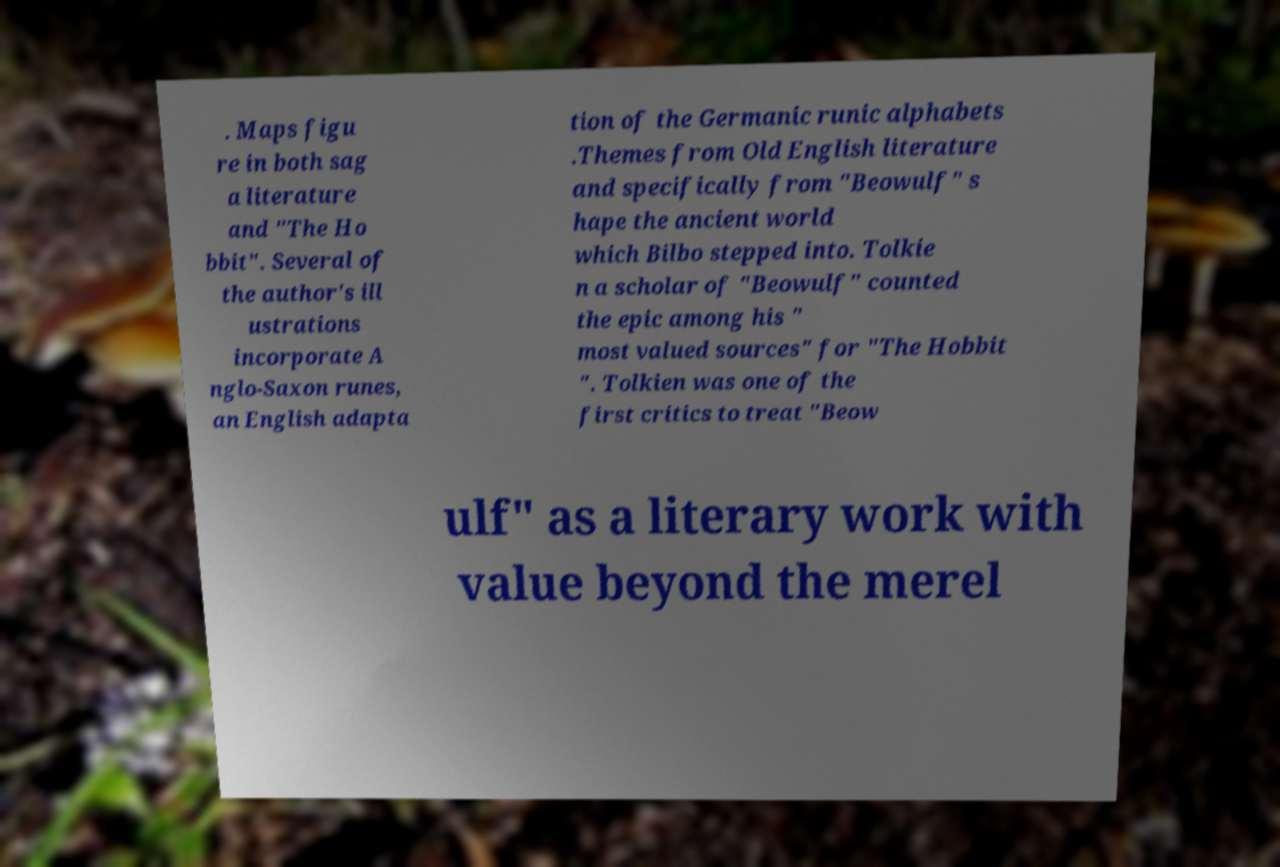Please read and relay the text visible in this image. What does it say? . Maps figu re in both sag a literature and "The Ho bbit". Several of the author's ill ustrations incorporate A nglo-Saxon runes, an English adapta tion of the Germanic runic alphabets .Themes from Old English literature and specifically from "Beowulf" s hape the ancient world which Bilbo stepped into. Tolkie n a scholar of "Beowulf" counted the epic among his " most valued sources" for "The Hobbit ". Tolkien was one of the first critics to treat "Beow ulf" as a literary work with value beyond the merel 